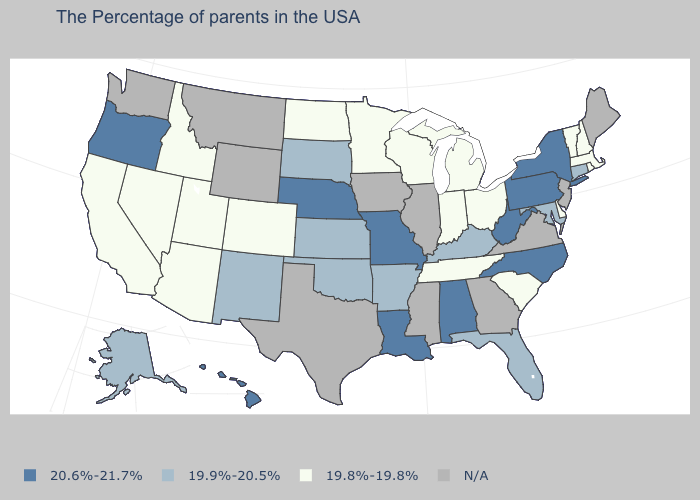Does Idaho have the lowest value in the West?
Be succinct. Yes. Is the legend a continuous bar?
Concise answer only. No. What is the value of Virginia?
Answer briefly. N/A. What is the value of New Hampshire?
Be succinct. 19.8%-19.8%. Among the states that border Tennessee , which have the lowest value?
Quick response, please. Kentucky, Arkansas. What is the value of Iowa?
Keep it brief. N/A. Name the states that have a value in the range 19.9%-20.5%?
Answer briefly. Connecticut, Maryland, Florida, Kentucky, Arkansas, Kansas, Oklahoma, South Dakota, New Mexico, Alaska. Is the legend a continuous bar?
Give a very brief answer. No. Does the map have missing data?
Be succinct. Yes. Does Nevada have the lowest value in the USA?
Write a very short answer. Yes. Does Vermont have the highest value in the Northeast?
Keep it brief. No. What is the value of Alaska?
Answer briefly. 19.9%-20.5%. What is the value of Wisconsin?
Be succinct. 19.8%-19.8%. What is the lowest value in the USA?
Give a very brief answer. 19.8%-19.8%. 